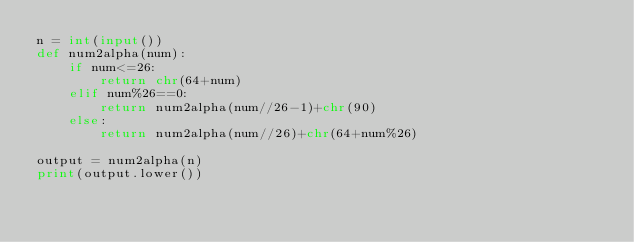Convert code to text. <code><loc_0><loc_0><loc_500><loc_500><_Python_>n = int(input())
def num2alpha(num):
    if num<=26:
        return chr(64+num)
    elif num%26==0:
        return num2alpha(num//26-1)+chr(90)
    else:
        return num2alpha(num//26)+chr(64+num%26)

output = num2alpha(n)
print(output.lower())
</code> 